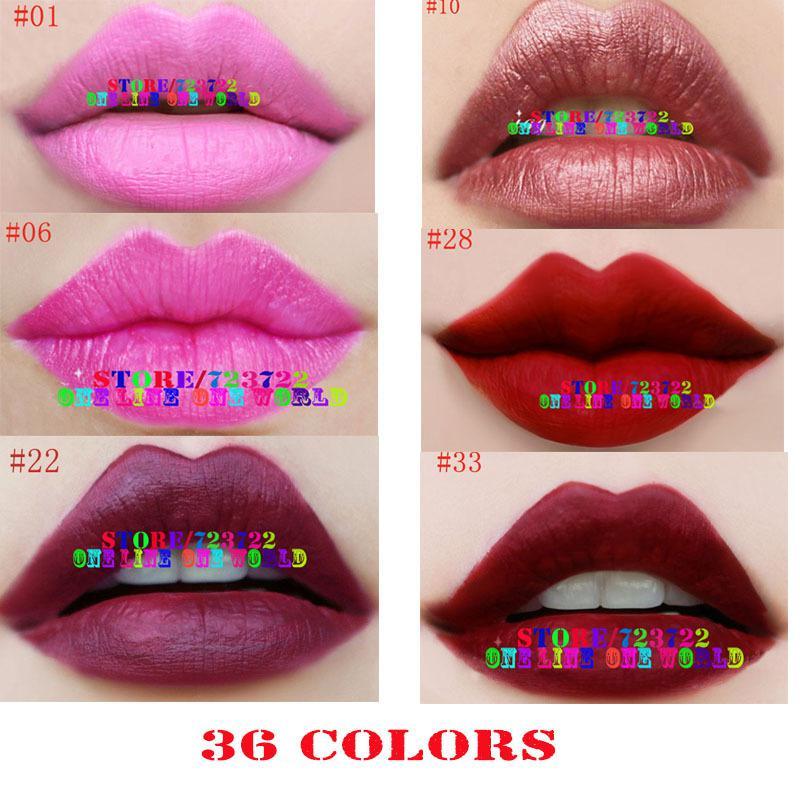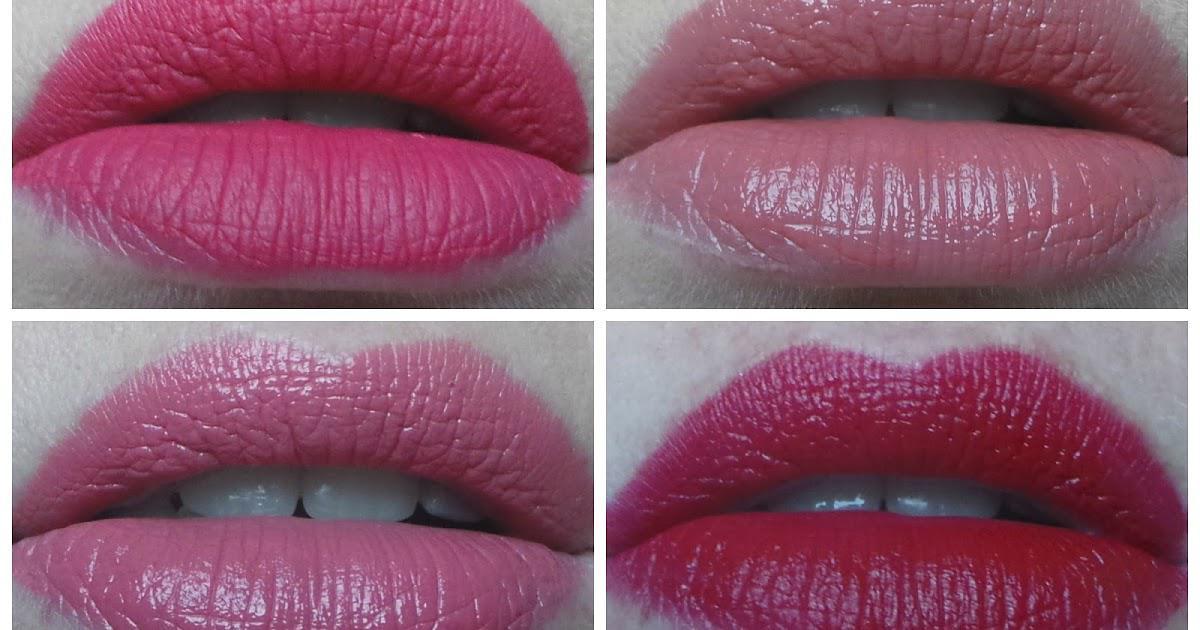The first image is the image on the left, the second image is the image on the right. Assess this claim about the two images: "One picture shows six or more pigments of lipstick swatched on a human arm.". Correct or not? Answer yes or no. No. 